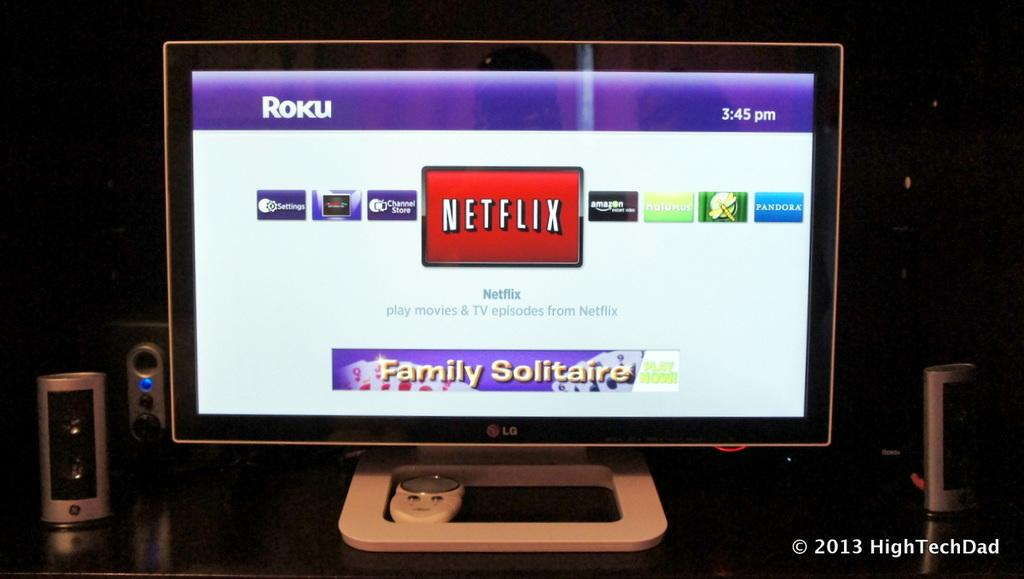<image>
Provide a brief description of the given image. A computer monitor shows the Roku screen wit the Netflix icon in the center of the screen and Family Solitaire at the bottom. 